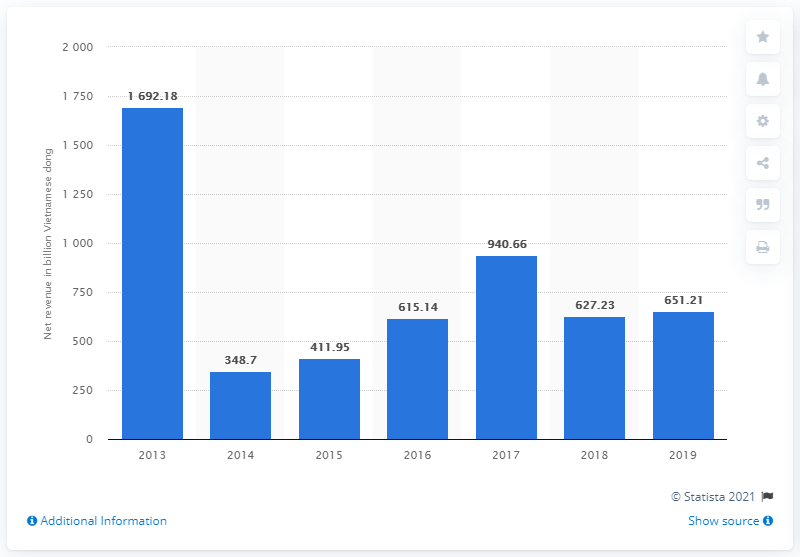Identify some key points in this picture. In 2019, MobiFone's net revenue was 651.21. 